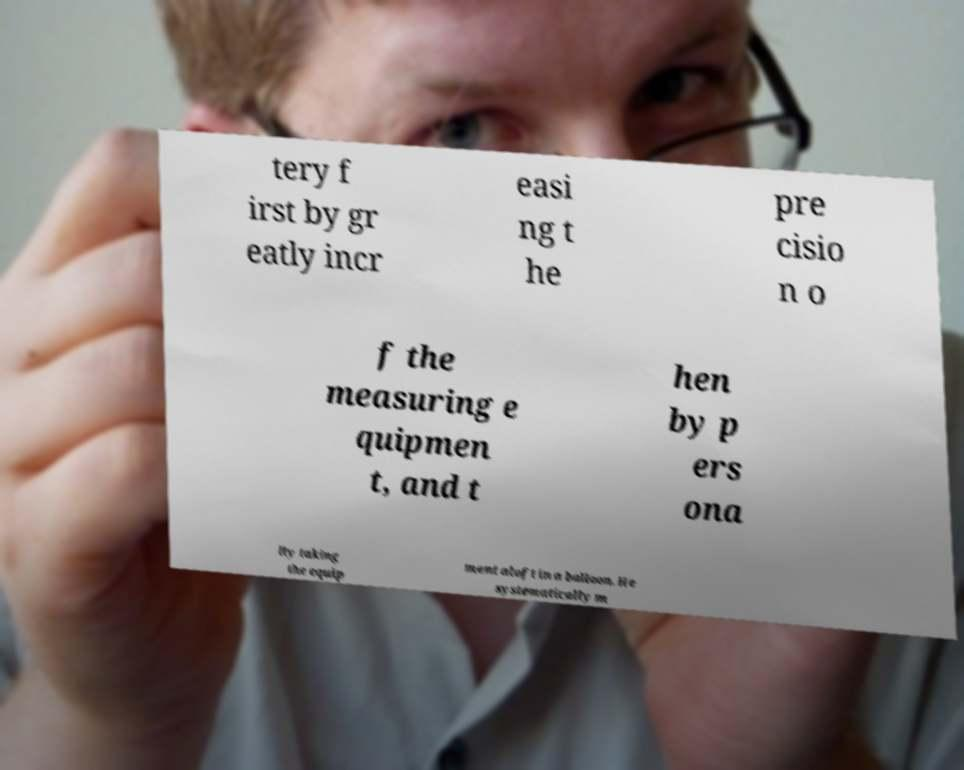What messages or text are displayed in this image? I need them in a readable, typed format. tery f irst by gr eatly incr easi ng t he pre cisio n o f the measuring e quipmen t, and t hen by p ers ona lly taking the equip ment aloft in a balloon. He systematically m 